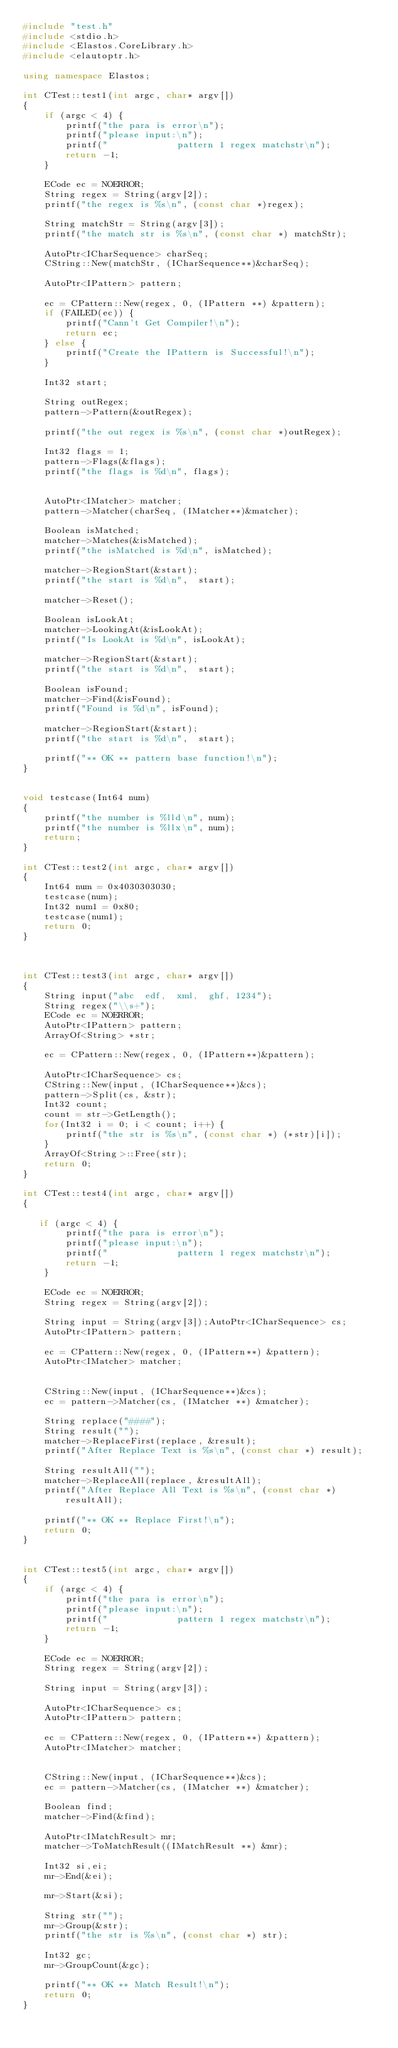Convert code to text. <code><loc_0><loc_0><loc_500><loc_500><_C++_>#include "test.h"
#include <stdio.h>
#include <Elastos.CoreLibrary.h>
#include <elautoptr.h>

using namespace Elastos;

int CTest::test1(int argc, char* argv[])
{
    if (argc < 4) {
        printf("the para is error\n");
        printf("please input:\n");
        printf("             pattern 1 regex matchstr\n");
        return -1;
    }

    ECode ec = NOERROR;
    String regex = String(argv[2]);
    printf("the regex is %s\n", (const char *)regex);

    String matchStr = String(argv[3]);
    printf("the match str is %s\n", (const char *) matchStr);

    AutoPtr<ICharSequence> charSeq;
    CString::New(matchStr, (ICharSequence**)&charSeq);

    AutoPtr<IPattern> pattern;

    ec = CPattern::New(regex, 0, (IPattern **) &pattern);
    if (FAILED(ec)) {
        printf("Cann't Get Compiler!\n");
        return ec;
    } else {
        printf("Create the IPattern is Successful!\n");
    }

    Int32 start;

    String outRegex;
    pattern->Pattern(&outRegex);

    printf("the out regex is %s\n", (const char *)outRegex);

    Int32 flags = 1;
    pattern->Flags(&flags);
    printf("the flags is %d\n", flags);


    AutoPtr<IMatcher> matcher;
    pattern->Matcher(charSeq, (IMatcher**)&matcher);

    Boolean isMatched;
    matcher->Matches(&isMatched);
    printf("the isMatched is %d\n", isMatched);

    matcher->RegionStart(&start);
    printf("the start is %d\n",  start);

    matcher->Reset();

    Boolean isLookAt;
    matcher->LookingAt(&isLookAt);
    printf("Is LookAt is %d\n", isLookAt);

    matcher->RegionStart(&start);
    printf("the start is %d\n",  start);

    Boolean isFound;
    matcher->Find(&isFound);
    printf("Found is %d\n", isFound);

    matcher->RegionStart(&start);
    printf("the start is %d\n",  start);

    printf("** OK ** pattern base function!\n");
}


void testcase(Int64 num)
{
    printf("the number is %lld\n", num);
    printf("the number is %llx\n", num);
    return;
}

int CTest::test2(int argc, char* argv[])
{
    Int64 num = 0x4030303030;
    testcase(num);
    Int32 num1 = 0x80;
    testcase(num1);
    return 0;
}



int CTest::test3(int argc, char* argv[])
{
    String input("abc  edf,  xml,  ghf, 1234");
    String regex("\\s+");
    ECode ec = NOERROR;
    AutoPtr<IPattern> pattern;
    ArrayOf<String> *str;

    ec = CPattern::New(regex, 0, (IPattern**)&pattern);

    AutoPtr<ICharSequence> cs;
    CString::New(input, (ICharSequence**)&cs);
    pattern->Split(cs, &str);
    Int32 count;
    count = str->GetLength();
    for(Int32 i = 0; i < count; i++) {
        printf("the str is %s\n", (const char *) (*str)[i]);
    }
    ArrayOf<String>::Free(str);
    return 0;
}

int CTest::test4(int argc, char* argv[])
{

   if (argc < 4) {
        printf("the para is error\n");
        printf("please input:\n");
        printf("             pattern 1 regex matchstr\n");
        return -1;
    }

    ECode ec = NOERROR;
    String regex = String(argv[2]);

    String input = String(argv[3]);AutoPtr<ICharSequence> cs;
    AutoPtr<IPattern> pattern;

    ec = CPattern::New(regex, 0, (IPattern**) &pattern);
    AutoPtr<IMatcher> matcher;


    CString::New(input, (ICharSequence**)&cs);
    ec = pattern->Matcher(cs, (IMatcher **) &matcher);

    String replace("####");
    String result("");
    matcher->ReplaceFirst(replace, &result);
    printf("After Replace Text is %s\n", (const char *) result);

    String resultAll("");
    matcher->ReplaceAll(replace, &resultAll);
    printf("After Replace All Text is %s\n", (const char *) resultAll);

    printf("** OK ** Replace First!\n");
    return 0;
}


int CTest::test5(int argc, char* argv[])
{
    if (argc < 4) {
        printf("the para is error\n");
        printf("please input:\n");
        printf("             pattern 1 regex matchstr\n");
        return -1;
    }

    ECode ec = NOERROR;
    String regex = String(argv[2]);

    String input = String(argv[3]);

    AutoPtr<ICharSequence> cs;
    AutoPtr<IPattern> pattern;

    ec = CPattern::New(regex, 0, (IPattern**) &pattern);
    AutoPtr<IMatcher> matcher;


    CString::New(input, (ICharSequence**)&cs);
    ec = pattern->Matcher(cs, (IMatcher **) &matcher);

    Boolean find;
    matcher->Find(&find);

    AutoPtr<IMatchResult> mr;
    matcher->ToMatchResult((IMatchResult **) &mr);

    Int32 si,ei;
    mr->End(&ei);

    mr->Start(&si);

    String str("");
    mr->Group(&str);
    printf("the str is %s\n", (const char *) str);

    Int32 gc;
    mr->GroupCount(&gc);

    printf("** OK ** Match Result!\n");
    return 0;
}
</code> 